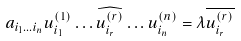<formula> <loc_0><loc_0><loc_500><loc_500>a _ { i _ { 1 } \dots i _ { n } } u _ { i _ { 1 } } ^ { ( 1 ) } \dots \widehat { u _ { i _ { r } } ^ { ( r ) } } \dots u _ { i _ { n } } ^ { ( n ) } = \lambda \overline { u _ { i _ { r } } ^ { ( r ) } }</formula> 